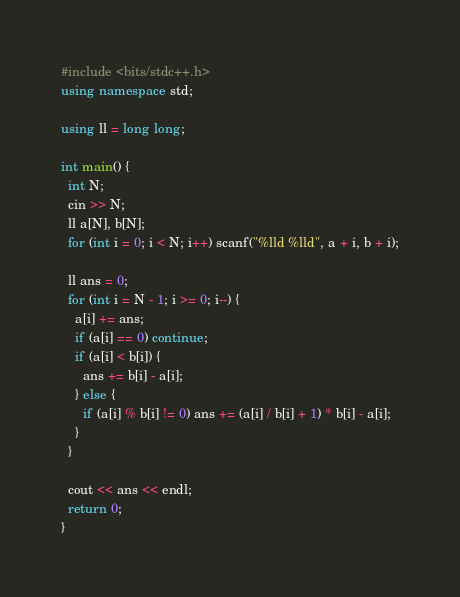Convert code to text. <code><loc_0><loc_0><loc_500><loc_500><_C++_>#include <bits/stdc++.h>
using namespace std;

using ll = long long;

int main() {
  int N;
  cin >> N;
  ll a[N], b[N];
  for (int i = 0; i < N; i++) scanf("%lld %lld", a + i, b + i);

  ll ans = 0;
  for (int i = N - 1; i >= 0; i--) {
    a[i] += ans;
    if (a[i] == 0) continue;
    if (a[i] < b[i]) {
      ans += b[i] - a[i];
    } else {
      if (a[i] % b[i] != 0) ans += (a[i] / b[i] + 1) * b[i] - a[i];
    }
  }

  cout << ans << endl;
  return 0;
}
</code> 